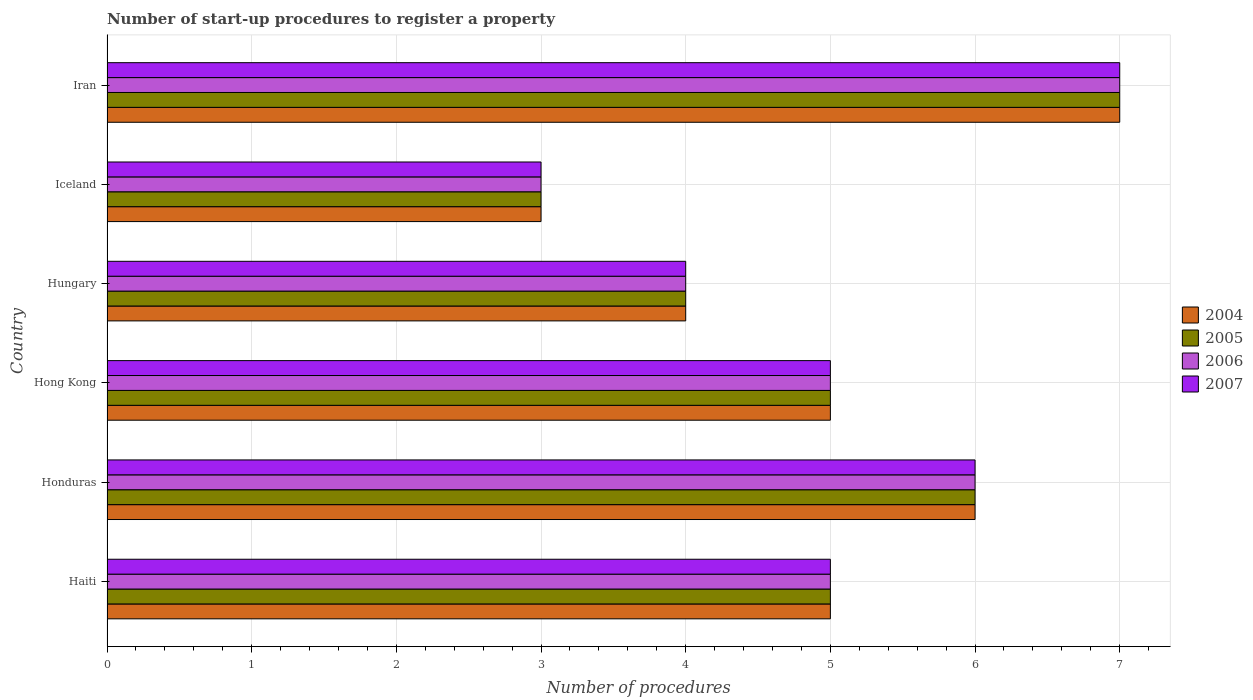How many groups of bars are there?
Provide a succinct answer. 6. Are the number of bars on each tick of the Y-axis equal?
Keep it short and to the point. Yes. How many bars are there on the 3rd tick from the top?
Offer a very short reply. 4. What is the label of the 1st group of bars from the top?
Keep it short and to the point. Iran. In how many cases, is the number of bars for a given country not equal to the number of legend labels?
Make the answer very short. 0. Across all countries, what is the maximum number of procedures required to register a property in 2004?
Your response must be concise. 7. Across all countries, what is the minimum number of procedures required to register a property in 2005?
Ensure brevity in your answer.  3. In which country was the number of procedures required to register a property in 2006 maximum?
Your response must be concise. Iran. In which country was the number of procedures required to register a property in 2007 minimum?
Make the answer very short. Iceland. What is the total number of procedures required to register a property in 2005 in the graph?
Your answer should be compact. 30. What is the average number of procedures required to register a property in 2004 per country?
Your answer should be compact. 5. What is the difference between the number of procedures required to register a property in 2004 and number of procedures required to register a property in 2007 in Hong Kong?
Ensure brevity in your answer.  0. In how many countries, is the number of procedures required to register a property in 2006 greater than 3.8 ?
Make the answer very short. 5. What is the ratio of the number of procedures required to register a property in 2005 in Honduras to that in Iran?
Your answer should be very brief. 0.86. Is the sum of the number of procedures required to register a property in 2005 in Haiti and Hong Kong greater than the maximum number of procedures required to register a property in 2006 across all countries?
Your response must be concise. Yes. What does the 1st bar from the top in Hungary represents?
Your answer should be very brief. 2007. Are all the bars in the graph horizontal?
Offer a very short reply. Yes. How many countries are there in the graph?
Give a very brief answer. 6. What is the difference between two consecutive major ticks on the X-axis?
Provide a succinct answer. 1. Are the values on the major ticks of X-axis written in scientific E-notation?
Ensure brevity in your answer.  No. Does the graph contain grids?
Offer a terse response. Yes. What is the title of the graph?
Ensure brevity in your answer.  Number of start-up procedures to register a property. What is the label or title of the X-axis?
Provide a succinct answer. Number of procedures. What is the label or title of the Y-axis?
Provide a succinct answer. Country. What is the Number of procedures in 2004 in Haiti?
Offer a terse response. 5. What is the Number of procedures in 2005 in Haiti?
Your answer should be compact. 5. What is the Number of procedures of 2006 in Haiti?
Ensure brevity in your answer.  5. What is the Number of procedures in 2007 in Haiti?
Give a very brief answer. 5. What is the Number of procedures in 2004 in Honduras?
Your response must be concise. 6. What is the Number of procedures in 2007 in Hong Kong?
Give a very brief answer. 5. What is the Number of procedures of 2004 in Hungary?
Your answer should be very brief. 4. What is the Number of procedures in 2005 in Hungary?
Provide a short and direct response. 4. What is the Number of procedures of 2006 in Hungary?
Keep it short and to the point. 4. What is the Number of procedures in 2007 in Hungary?
Your response must be concise. 4. What is the Number of procedures of 2007 in Iceland?
Your answer should be compact. 3. What is the Number of procedures of 2004 in Iran?
Provide a short and direct response. 7. What is the Number of procedures of 2006 in Iran?
Your response must be concise. 7. Across all countries, what is the maximum Number of procedures of 2006?
Ensure brevity in your answer.  7. Across all countries, what is the maximum Number of procedures in 2007?
Your response must be concise. 7. Across all countries, what is the minimum Number of procedures in 2004?
Ensure brevity in your answer.  3. Across all countries, what is the minimum Number of procedures of 2005?
Your answer should be very brief. 3. Across all countries, what is the minimum Number of procedures in 2006?
Give a very brief answer. 3. What is the difference between the Number of procedures in 2004 in Haiti and that in Honduras?
Provide a short and direct response. -1. What is the difference between the Number of procedures in 2007 in Haiti and that in Honduras?
Offer a terse response. -1. What is the difference between the Number of procedures in 2004 in Haiti and that in Hong Kong?
Ensure brevity in your answer.  0. What is the difference between the Number of procedures in 2005 in Haiti and that in Hong Kong?
Your response must be concise. 0. What is the difference between the Number of procedures in 2004 in Haiti and that in Hungary?
Give a very brief answer. 1. What is the difference between the Number of procedures of 2005 in Haiti and that in Iceland?
Offer a very short reply. 2. What is the difference between the Number of procedures in 2006 in Haiti and that in Iceland?
Offer a very short reply. 2. What is the difference between the Number of procedures of 2005 in Haiti and that in Iran?
Keep it short and to the point. -2. What is the difference between the Number of procedures in 2007 in Honduras and that in Hong Kong?
Offer a very short reply. 1. What is the difference between the Number of procedures of 2004 in Honduras and that in Hungary?
Ensure brevity in your answer.  2. What is the difference between the Number of procedures in 2004 in Honduras and that in Iceland?
Provide a succinct answer. 3. What is the difference between the Number of procedures in 2005 in Honduras and that in Iceland?
Provide a succinct answer. 3. What is the difference between the Number of procedures in 2005 in Honduras and that in Iran?
Your response must be concise. -1. What is the difference between the Number of procedures of 2005 in Hong Kong and that in Hungary?
Offer a terse response. 1. What is the difference between the Number of procedures in 2006 in Hong Kong and that in Hungary?
Your response must be concise. 1. What is the difference between the Number of procedures of 2005 in Hong Kong and that in Iceland?
Provide a succinct answer. 2. What is the difference between the Number of procedures of 2006 in Hong Kong and that in Iceland?
Keep it short and to the point. 2. What is the difference between the Number of procedures in 2005 in Hong Kong and that in Iran?
Your answer should be compact. -2. What is the difference between the Number of procedures in 2006 in Hong Kong and that in Iran?
Keep it short and to the point. -2. What is the difference between the Number of procedures of 2007 in Hong Kong and that in Iran?
Offer a very short reply. -2. What is the difference between the Number of procedures in 2005 in Hungary and that in Iceland?
Your answer should be compact. 1. What is the difference between the Number of procedures of 2006 in Hungary and that in Iceland?
Make the answer very short. 1. What is the difference between the Number of procedures in 2007 in Hungary and that in Iceland?
Ensure brevity in your answer.  1. What is the difference between the Number of procedures in 2004 in Hungary and that in Iran?
Your answer should be very brief. -3. What is the difference between the Number of procedures of 2007 in Iceland and that in Iran?
Your answer should be compact. -4. What is the difference between the Number of procedures of 2004 in Haiti and the Number of procedures of 2006 in Honduras?
Your answer should be very brief. -1. What is the difference between the Number of procedures in 2004 in Haiti and the Number of procedures in 2007 in Honduras?
Your response must be concise. -1. What is the difference between the Number of procedures of 2004 in Haiti and the Number of procedures of 2005 in Hong Kong?
Offer a terse response. 0. What is the difference between the Number of procedures in 2004 in Haiti and the Number of procedures in 2006 in Hong Kong?
Give a very brief answer. 0. What is the difference between the Number of procedures in 2004 in Haiti and the Number of procedures in 2005 in Hungary?
Ensure brevity in your answer.  1. What is the difference between the Number of procedures in 2004 in Haiti and the Number of procedures in 2006 in Hungary?
Ensure brevity in your answer.  1. What is the difference between the Number of procedures in 2004 in Haiti and the Number of procedures in 2007 in Hungary?
Your response must be concise. 1. What is the difference between the Number of procedures of 2005 in Haiti and the Number of procedures of 2007 in Hungary?
Provide a short and direct response. 1. What is the difference between the Number of procedures in 2006 in Haiti and the Number of procedures in 2007 in Hungary?
Make the answer very short. 1. What is the difference between the Number of procedures of 2004 in Haiti and the Number of procedures of 2005 in Iceland?
Ensure brevity in your answer.  2. What is the difference between the Number of procedures in 2004 in Haiti and the Number of procedures in 2007 in Iceland?
Provide a succinct answer. 2. What is the difference between the Number of procedures of 2005 in Haiti and the Number of procedures of 2006 in Iceland?
Give a very brief answer. 2. What is the difference between the Number of procedures of 2005 in Haiti and the Number of procedures of 2007 in Iceland?
Your response must be concise. 2. What is the difference between the Number of procedures of 2005 in Haiti and the Number of procedures of 2006 in Iran?
Keep it short and to the point. -2. What is the difference between the Number of procedures of 2005 in Haiti and the Number of procedures of 2007 in Iran?
Give a very brief answer. -2. What is the difference between the Number of procedures in 2005 in Honduras and the Number of procedures in 2006 in Hong Kong?
Provide a short and direct response. 1. What is the difference between the Number of procedures in 2005 in Honduras and the Number of procedures in 2007 in Hong Kong?
Your response must be concise. 1. What is the difference between the Number of procedures in 2006 in Honduras and the Number of procedures in 2007 in Hong Kong?
Give a very brief answer. 1. What is the difference between the Number of procedures in 2004 in Honduras and the Number of procedures in 2006 in Hungary?
Your response must be concise. 2. What is the difference between the Number of procedures of 2005 in Honduras and the Number of procedures of 2006 in Hungary?
Ensure brevity in your answer.  2. What is the difference between the Number of procedures in 2006 in Honduras and the Number of procedures in 2007 in Hungary?
Your answer should be compact. 2. What is the difference between the Number of procedures in 2004 in Honduras and the Number of procedures in 2005 in Iceland?
Provide a short and direct response. 3. What is the difference between the Number of procedures of 2005 in Honduras and the Number of procedures of 2007 in Iceland?
Your answer should be very brief. 3. What is the difference between the Number of procedures of 2006 in Honduras and the Number of procedures of 2007 in Iceland?
Your response must be concise. 3. What is the difference between the Number of procedures in 2004 in Honduras and the Number of procedures in 2005 in Iran?
Your response must be concise. -1. What is the difference between the Number of procedures of 2004 in Honduras and the Number of procedures of 2007 in Iran?
Make the answer very short. -1. What is the difference between the Number of procedures in 2005 in Honduras and the Number of procedures in 2006 in Iran?
Your response must be concise. -1. What is the difference between the Number of procedures of 2006 in Honduras and the Number of procedures of 2007 in Iran?
Your answer should be compact. -1. What is the difference between the Number of procedures of 2006 in Hong Kong and the Number of procedures of 2007 in Hungary?
Your answer should be very brief. 1. What is the difference between the Number of procedures in 2004 in Hong Kong and the Number of procedures in 2006 in Iceland?
Offer a terse response. 2. What is the difference between the Number of procedures of 2004 in Hong Kong and the Number of procedures of 2007 in Iceland?
Provide a succinct answer. 2. What is the difference between the Number of procedures of 2005 in Hong Kong and the Number of procedures of 2007 in Iceland?
Make the answer very short. 2. What is the difference between the Number of procedures of 2006 in Hong Kong and the Number of procedures of 2007 in Iceland?
Provide a short and direct response. 2. What is the difference between the Number of procedures of 2004 in Hong Kong and the Number of procedures of 2006 in Iran?
Make the answer very short. -2. What is the difference between the Number of procedures of 2004 in Hong Kong and the Number of procedures of 2007 in Iran?
Make the answer very short. -2. What is the difference between the Number of procedures in 2005 in Hong Kong and the Number of procedures in 2007 in Iran?
Ensure brevity in your answer.  -2. What is the difference between the Number of procedures of 2006 in Hong Kong and the Number of procedures of 2007 in Iran?
Offer a very short reply. -2. What is the difference between the Number of procedures in 2004 in Hungary and the Number of procedures in 2005 in Iceland?
Your response must be concise. 1. What is the difference between the Number of procedures in 2004 in Hungary and the Number of procedures in 2006 in Iceland?
Keep it short and to the point. 1. What is the difference between the Number of procedures in 2005 in Hungary and the Number of procedures in 2006 in Iceland?
Offer a terse response. 1. What is the difference between the Number of procedures of 2005 in Hungary and the Number of procedures of 2007 in Iceland?
Give a very brief answer. 1. What is the difference between the Number of procedures of 2004 in Hungary and the Number of procedures of 2006 in Iran?
Your answer should be very brief. -3. What is the difference between the Number of procedures in 2004 in Hungary and the Number of procedures in 2007 in Iran?
Offer a terse response. -3. What is the difference between the Number of procedures in 2005 in Hungary and the Number of procedures in 2007 in Iran?
Ensure brevity in your answer.  -3. What is the difference between the Number of procedures of 2006 in Hungary and the Number of procedures of 2007 in Iran?
Offer a very short reply. -3. What is the difference between the Number of procedures in 2004 in Iceland and the Number of procedures in 2005 in Iran?
Provide a short and direct response. -4. What is the difference between the Number of procedures in 2004 in Iceland and the Number of procedures in 2006 in Iran?
Provide a succinct answer. -4. What is the average Number of procedures of 2004 per country?
Give a very brief answer. 5. What is the average Number of procedures of 2005 per country?
Your answer should be compact. 5. What is the average Number of procedures of 2006 per country?
Ensure brevity in your answer.  5. What is the average Number of procedures in 2007 per country?
Provide a short and direct response. 5. What is the difference between the Number of procedures in 2004 and Number of procedures in 2005 in Haiti?
Provide a succinct answer. 0. What is the difference between the Number of procedures of 2004 and Number of procedures of 2006 in Haiti?
Provide a succinct answer. 0. What is the difference between the Number of procedures of 2004 and Number of procedures of 2007 in Haiti?
Keep it short and to the point. 0. What is the difference between the Number of procedures of 2005 and Number of procedures of 2006 in Haiti?
Make the answer very short. 0. What is the difference between the Number of procedures of 2005 and Number of procedures of 2007 in Haiti?
Provide a short and direct response. 0. What is the difference between the Number of procedures in 2006 and Number of procedures in 2007 in Haiti?
Offer a terse response. 0. What is the difference between the Number of procedures in 2004 and Number of procedures in 2005 in Honduras?
Make the answer very short. 0. What is the difference between the Number of procedures in 2005 and Number of procedures in 2006 in Honduras?
Keep it short and to the point. 0. What is the difference between the Number of procedures of 2006 and Number of procedures of 2007 in Honduras?
Your answer should be compact. 0. What is the difference between the Number of procedures in 2004 and Number of procedures in 2005 in Hong Kong?
Make the answer very short. 0. What is the difference between the Number of procedures in 2004 and Number of procedures in 2007 in Hong Kong?
Provide a succinct answer. 0. What is the difference between the Number of procedures of 2005 and Number of procedures of 2007 in Hong Kong?
Your answer should be very brief. 0. What is the difference between the Number of procedures in 2004 and Number of procedures in 2006 in Hungary?
Provide a succinct answer. 0. What is the difference between the Number of procedures in 2004 and Number of procedures in 2007 in Hungary?
Offer a terse response. 0. What is the difference between the Number of procedures in 2005 and Number of procedures in 2007 in Hungary?
Your answer should be compact. 0. What is the difference between the Number of procedures of 2004 and Number of procedures of 2006 in Iceland?
Offer a terse response. 0. What is the difference between the Number of procedures of 2004 and Number of procedures of 2007 in Iceland?
Keep it short and to the point. 0. What is the difference between the Number of procedures in 2005 and Number of procedures in 2007 in Iceland?
Keep it short and to the point. 0. What is the difference between the Number of procedures of 2004 and Number of procedures of 2005 in Iran?
Ensure brevity in your answer.  0. What is the difference between the Number of procedures in 2004 and Number of procedures in 2006 in Iran?
Keep it short and to the point. 0. What is the difference between the Number of procedures in 2004 and Number of procedures in 2007 in Iran?
Offer a terse response. 0. What is the difference between the Number of procedures of 2006 and Number of procedures of 2007 in Iran?
Give a very brief answer. 0. What is the ratio of the Number of procedures in 2005 in Haiti to that in Honduras?
Ensure brevity in your answer.  0.83. What is the ratio of the Number of procedures in 2006 in Haiti to that in Honduras?
Provide a succinct answer. 0.83. What is the ratio of the Number of procedures in 2004 in Haiti to that in Hong Kong?
Your answer should be very brief. 1. What is the ratio of the Number of procedures of 2007 in Haiti to that in Hong Kong?
Your answer should be very brief. 1. What is the ratio of the Number of procedures in 2004 in Haiti to that in Hungary?
Ensure brevity in your answer.  1.25. What is the ratio of the Number of procedures in 2006 in Haiti to that in Hungary?
Keep it short and to the point. 1.25. What is the ratio of the Number of procedures of 2007 in Haiti to that in Hungary?
Make the answer very short. 1.25. What is the ratio of the Number of procedures of 2004 in Haiti to that in Iceland?
Provide a succinct answer. 1.67. What is the ratio of the Number of procedures of 2005 in Haiti to that in Iran?
Make the answer very short. 0.71. What is the ratio of the Number of procedures in 2006 in Haiti to that in Iran?
Your answer should be compact. 0.71. What is the ratio of the Number of procedures in 2005 in Honduras to that in Hong Kong?
Your response must be concise. 1.2. What is the ratio of the Number of procedures of 2006 in Honduras to that in Hungary?
Your answer should be compact. 1.5. What is the ratio of the Number of procedures in 2007 in Honduras to that in Hungary?
Your response must be concise. 1.5. What is the ratio of the Number of procedures in 2004 in Honduras to that in Iceland?
Your response must be concise. 2. What is the ratio of the Number of procedures in 2006 in Honduras to that in Iceland?
Offer a very short reply. 2. What is the ratio of the Number of procedures of 2007 in Honduras to that in Iceland?
Give a very brief answer. 2. What is the ratio of the Number of procedures of 2004 in Honduras to that in Iran?
Make the answer very short. 0.86. What is the ratio of the Number of procedures in 2005 in Honduras to that in Iran?
Provide a succinct answer. 0.86. What is the ratio of the Number of procedures of 2006 in Honduras to that in Iran?
Your response must be concise. 0.86. What is the ratio of the Number of procedures of 2007 in Honduras to that in Iran?
Provide a short and direct response. 0.86. What is the ratio of the Number of procedures of 2004 in Hong Kong to that in Hungary?
Offer a very short reply. 1.25. What is the ratio of the Number of procedures in 2005 in Hong Kong to that in Hungary?
Your answer should be compact. 1.25. What is the ratio of the Number of procedures of 2007 in Hong Kong to that in Hungary?
Offer a very short reply. 1.25. What is the ratio of the Number of procedures in 2004 in Hong Kong to that in Iceland?
Offer a terse response. 1.67. What is the ratio of the Number of procedures of 2007 in Hong Kong to that in Iceland?
Offer a terse response. 1.67. What is the ratio of the Number of procedures in 2007 in Hong Kong to that in Iran?
Provide a short and direct response. 0.71. What is the ratio of the Number of procedures in 2006 in Hungary to that in Iceland?
Ensure brevity in your answer.  1.33. What is the ratio of the Number of procedures in 2004 in Hungary to that in Iran?
Make the answer very short. 0.57. What is the ratio of the Number of procedures in 2006 in Hungary to that in Iran?
Your response must be concise. 0.57. What is the ratio of the Number of procedures in 2007 in Hungary to that in Iran?
Give a very brief answer. 0.57. What is the ratio of the Number of procedures of 2004 in Iceland to that in Iran?
Your response must be concise. 0.43. What is the ratio of the Number of procedures in 2005 in Iceland to that in Iran?
Keep it short and to the point. 0.43. What is the ratio of the Number of procedures of 2006 in Iceland to that in Iran?
Your answer should be compact. 0.43. What is the ratio of the Number of procedures in 2007 in Iceland to that in Iran?
Provide a short and direct response. 0.43. What is the difference between the highest and the lowest Number of procedures of 2004?
Your answer should be compact. 4. What is the difference between the highest and the lowest Number of procedures in 2006?
Offer a terse response. 4. What is the difference between the highest and the lowest Number of procedures of 2007?
Ensure brevity in your answer.  4. 